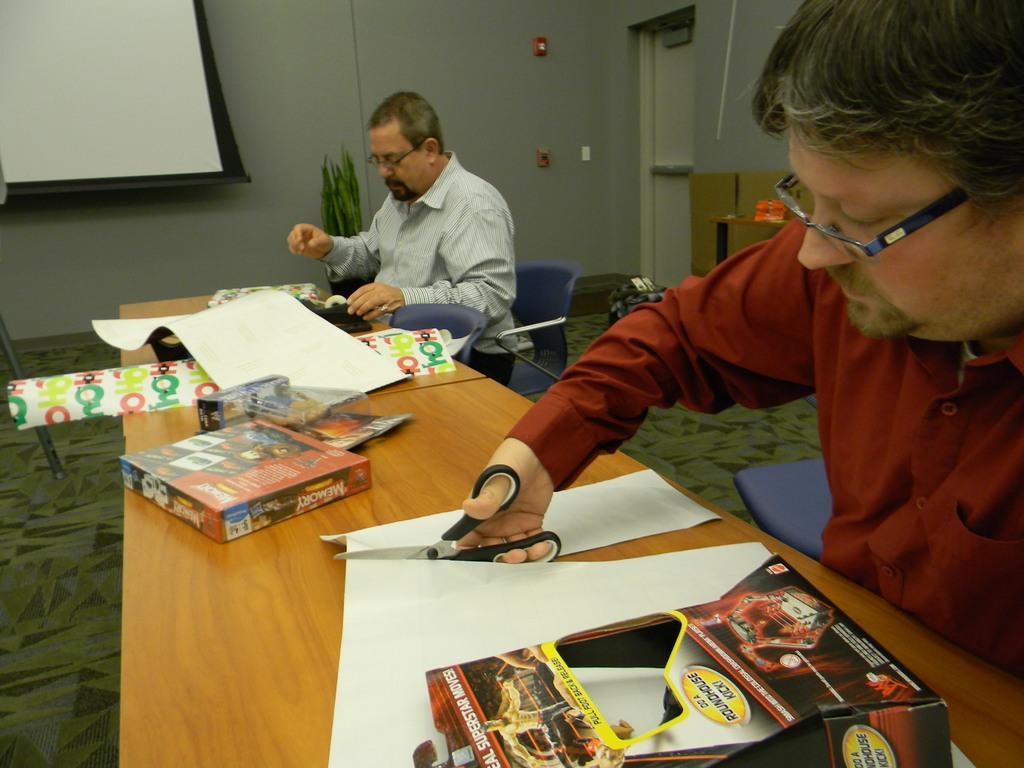In one or two sentences, can you explain what this image depicts? In this image, we can see persons persons wearing clothes and sitting on chairs in front of the table. This table contains boxes and papers. There is a person on the right side of the image cutting paper with scissors. There is a screen in the top left of the image. 